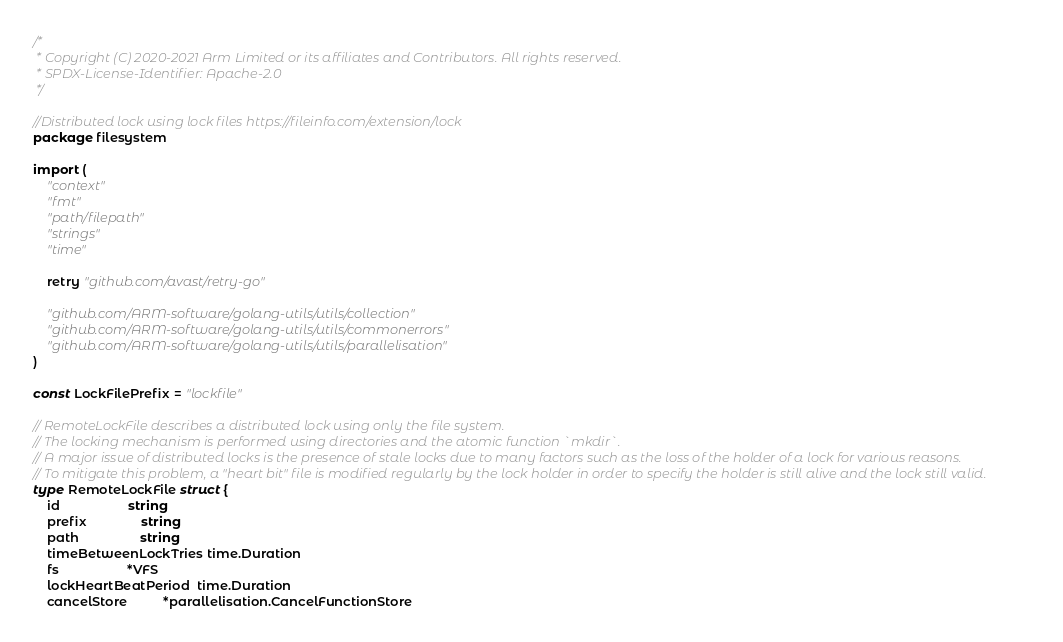<code> <loc_0><loc_0><loc_500><loc_500><_Go_>/*
 * Copyright (C) 2020-2021 Arm Limited or its affiliates and Contributors. All rights reserved.
 * SPDX-License-Identifier: Apache-2.0
 */

//Distributed lock using lock files https://fileinfo.com/extension/lock
package filesystem

import (
	"context"
	"fmt"
	"path/filepath"
	"strings"
	"time"

	retry "github.com/avast/retry-go"

	"github.com/ARM-software/golang-utils/utils/collection"
	"github.com/ARM-software/golang-utils/utils/commonerrors"
	"github.com/ARM-software/golang-utils/utils/parallelisation"
)

const LockFilePrefix = "lockfile"

// RemoteLockFile describes a distributed lock using only the file system.
// The locking mechanism is performed using directories and the atomic function `mkdir`.
// A major issue of distributed locks is the presence of stale locks due to many factors such as the loss of the holder of a lock for various reasons.
// To mitigate this problem, a "heart bit" file is modified regularly by the lock holder in order to specify the holder is still alive and the lock still valid.
type RemoteLockFile struct {
	id                   string
	prefix               string
	path                 string
	timeBetweenLockTries time.Duration
	fs                   *VFS
	lockHeartBeatPeriod  time.Duration
	cancelStore          *parallelisation.CancelFunctionStore</code> 